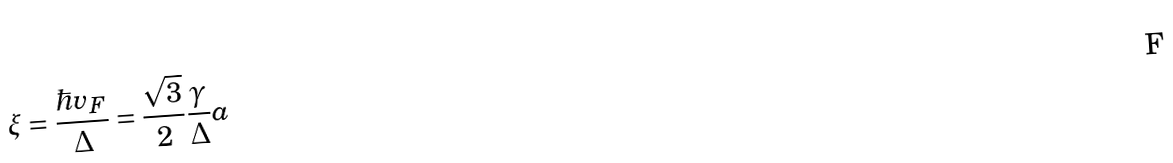<formula> <loc_0><loc_0><loc_500><loc_500>\xi = \frac { \hbar { v } _ { F } } { \Delta } = \frac { \sqrt { 3 } } { 2 } \frac { \gamma } { \Delta } a</formula> 